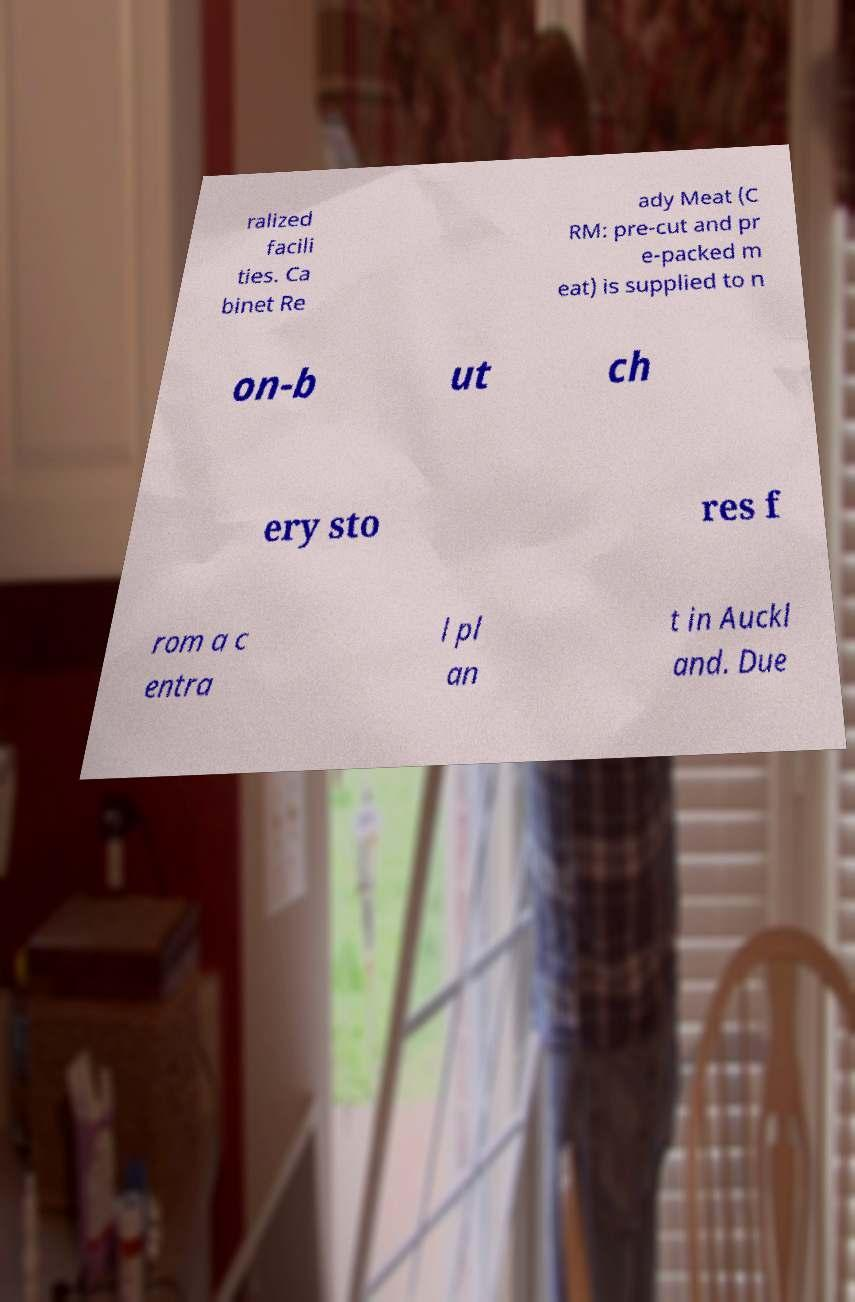Could you extract and type out the text from this image? ralized facili ties. Ca binet Re ady Meat (C RM: pre-cut and pr e-packed m eat) is supplied to n on-b ut ch ery sto res f rom a c entra l pl an t in Auckl and. Due 